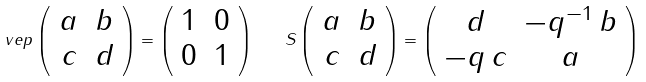Convert formula to latex. <formula><loc_0><loc_0><loc_500><loc_500>\ v e p \left ( \begin{array} { c c } a & b \\ c & d \end{array} \right ) = \left ( \begin{array} { c c } 1 & 0 \\ 0 & 1 \end{array} \right ) \quad S \left ( \begin{array} { c c } a & b \\ c & d \end{array} \right ) = \left ( \begin{array} { c c } d & - q ^ { - 1 } \, b \\ - q \, c & a \end{array} \right )</formula> 